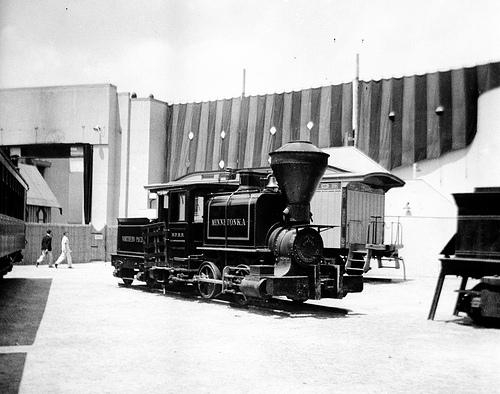How many locomotives are there in the image, and what features can you identify in them? There is one small locomotive in the image, featuring a large black stack, a boiler, a cabin, and steel wheels. Identify the objects causing the dark shadows on the left side of the image. The train cars on the left are the cause of the two dark shadows visible on the ground. Describe the overall mood of the image. The image has a nostalgic atmosphere, capturing an old-fashioned train and people walking nearby in a black and white photograph. Enumerate the objects that people are wearing, and mention if they are white, black or other color. The objects people are wearing include a black coat, a white shirt, and white pants. What type of transport can be seen in the image? An old-style train engine and freight car. Analyze the quality and lighting of the image. The image is a black and white photo with good contrast, displaying clear object details in even lighting and some cast shadows. Identify the primary structure present in the background. A large cement block building forms the predominant structure in the background. Count the number of people visible in the image and describe what they are wearing. There are two people walking together, one in all white attire and the other with a dark top and white pants. Examine the enclosure in the image and describe its contents. The enclosure includes a small locomotive, two people walking, the edge of a train freight car, a wooden fence, and a striped tent over a wall. Analyze the interaction between the objects in the image. There are two men walking together near the train, possibly observing or admiring it, and a wooden fence nearby, separating them from the train. 